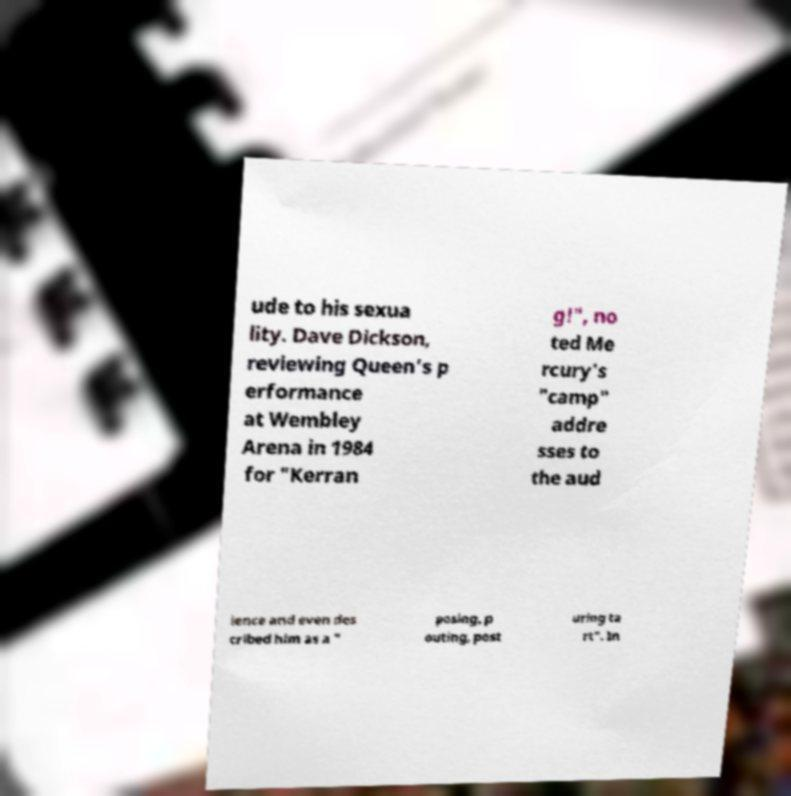Can you read and provide the text displayed in the image?This photo seems to have some interesting text. Can you extract and type it out for me? ude to his sexua lity. Dave Dickson, reviewing Queen's p erformance at Wembley Arena in 1984 for "Kerran g!", no ted Me rcury's "camp" addre sses to the aud ience and even des cribed him as a " posing, p outing, post uring ta rt". In 